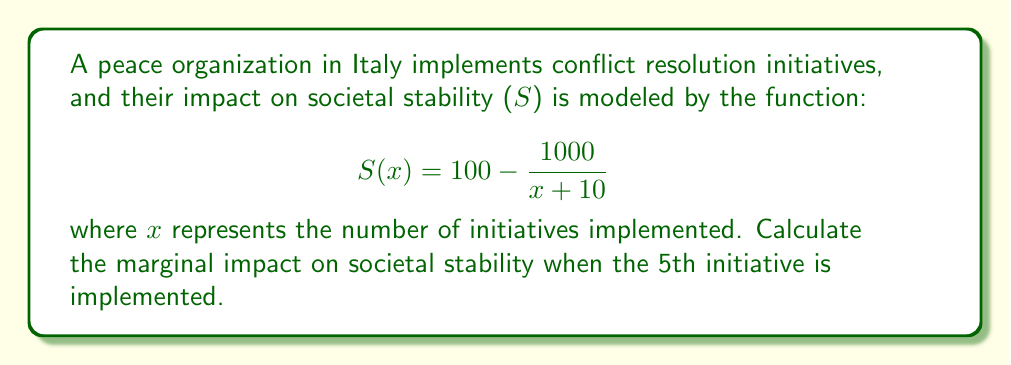Show me your answer to this math problem. To find the marginal impact, we need to calculate the derivative of the function S(x) and evaluate it at x = 5.

Step 1: Calculate the derivative of S(x)
$$\frac{d}{dx}S(x) = \frac{d}{dx}(100 - \frac{1000}{x + 10})$$
$$= 0 - (-1000) \cdot \frac{d}{dx}(x + 10)^{-1}$$
$$= 1000 \cdot (-1)(x + 10)^{-2}$$
$$= \frac{1000}{(x + 10)^2}$$

Step 2: Evaluate the derivative at x = 5
$$\frac{dS}{dx}(5) = \frac{1000}{(5 + 10)^2}$$
$$= \frac{1000}{15^2}$$
$$= \frac{1000}{225}$$
$$\approx 4.44$$

This means that when the 5th initiative is implemented, the marginal impact on societal stability is approximately 4.44 units.
Answer: $\frac{1000}{225}$ or approximately 4.44 